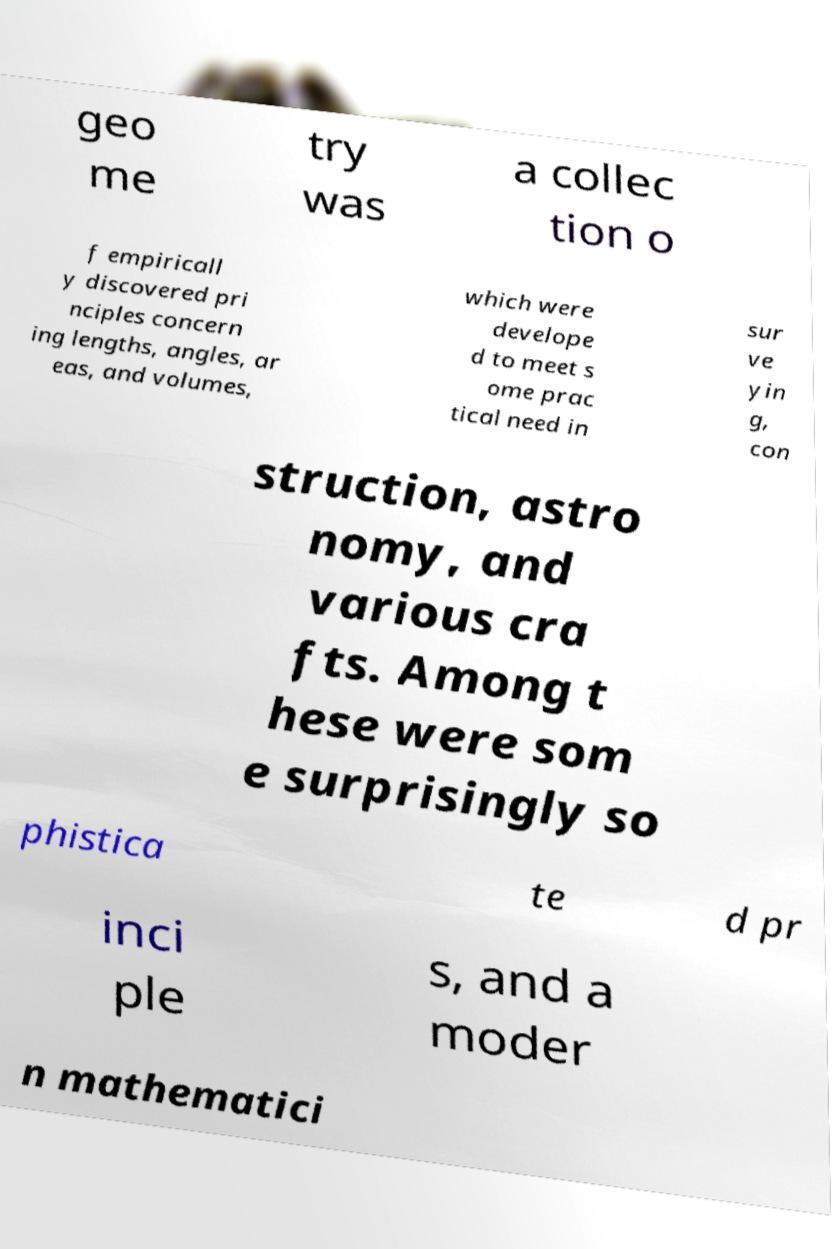Could you assist in decoding the text presented in this image and type it out clearly? geo me try was a collec tion o f empiricall y discovered pri nciples concern ing lengths, angles, ar eas, and volumes, which were develope d to meet s ome prac tical need in sur ve yin g, con struction, astro nomy, and various cra fts. Among t hese were som e surprisingly so phistica te d pr inci ple s, and a moder n mathematici 